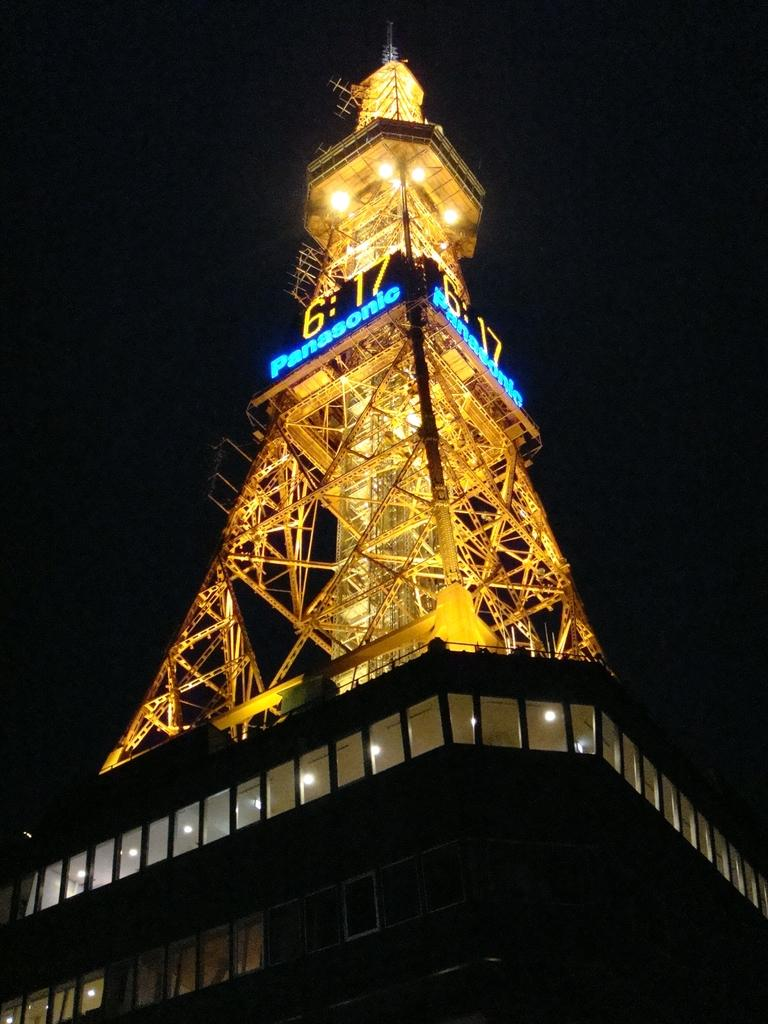What is the main structure in the image? There is a tower in the image. What feature can be seen on the tower? The tower has lights on it. What can be observed about the background of the image? There is a dark background in the image. What is the rate of the suit falling from the tower in the image? There is no suit present in the image, and therefore no rate of falling can be determined. 